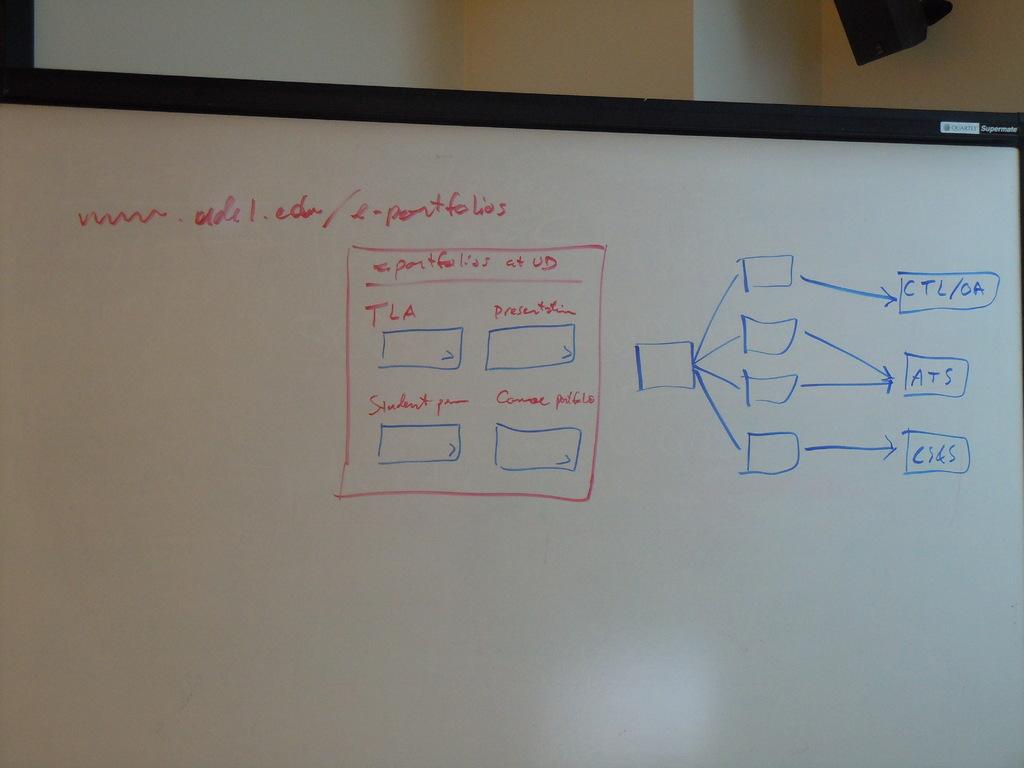What is the title of the diagram in the red box?
Provide a succinct answer. Portfolios at ud. 